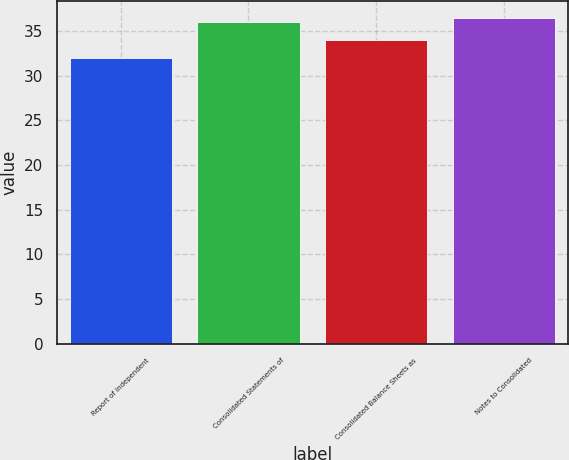Convert chart. <chart><loc_0><loc_0><loc_500><loc_500><bar_chart><fcel>Report of Independent<fcel>Consolidated Statements of<fcel>Consolidated Balance Sheets as<fcel>Notes to Consolidated<nl><fcel>32<fcel>36<fcel>34<fcel>36.5<nl></chart> 